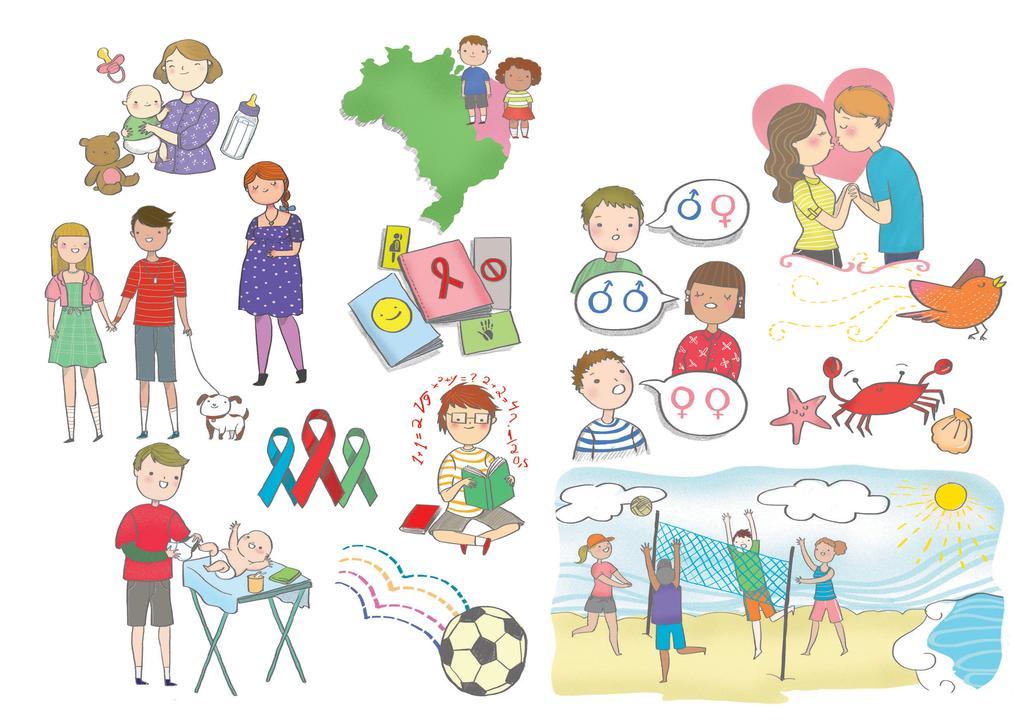How would you summarize this image in a sentence or two? In the picture I can see the paintings. I can see the painting of four persons playing a game on the bottom right side. There is a painting of a boy reading a book. I can see the painting of a couple on the top right side. There is a bird, a scorpion and a starfish on the right side. I can see the painting of a baby on the table on the bottom left side. There is a woman holding a baby on the top left side. 